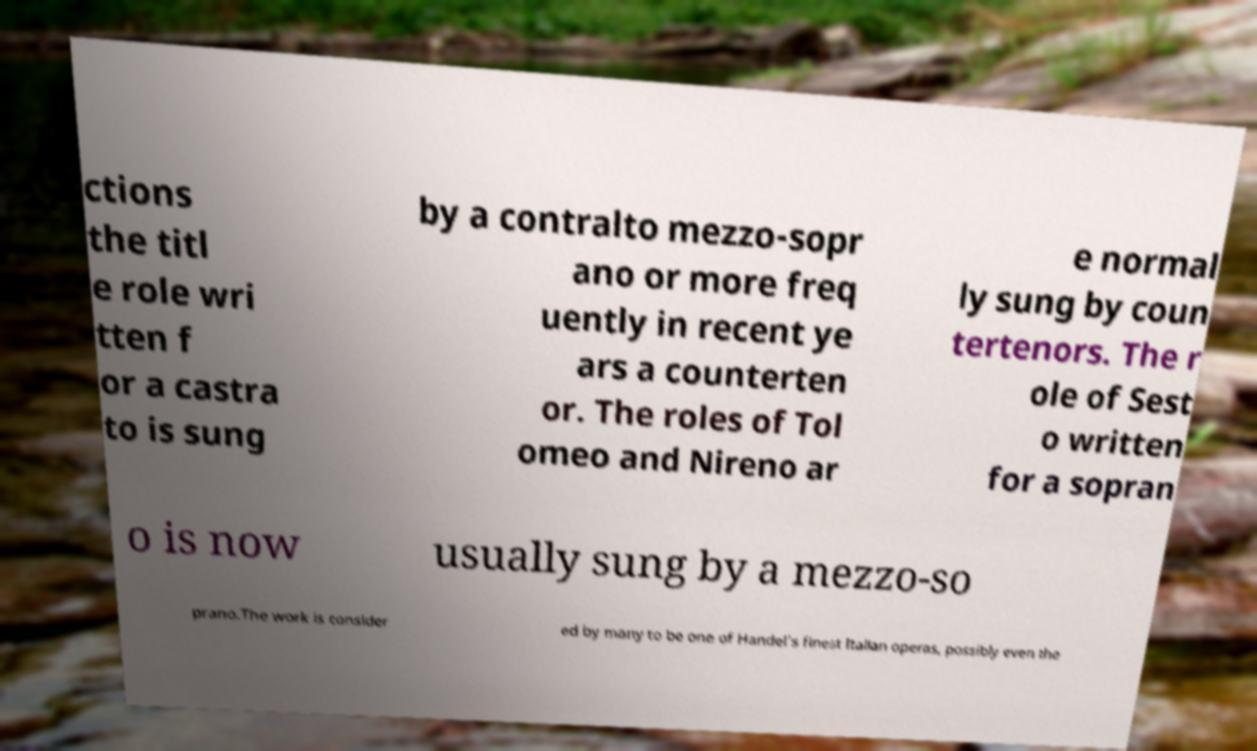Please identify and transcribe the text found in this image. ctions the titl e role wri tten f or a castra to is sung by a contralto mezzo-sopr ano or more freq uently in recent ye ars a counterten or. The roles of Tol omeo and Nireno ar e normal ly sung by coun tertenors. The r ole of Sest o written for a sopran o is now usually sung by a mezzo-so prano.The work is consider ed by many to be one of Handel's finest Italian operas, possibly even the 